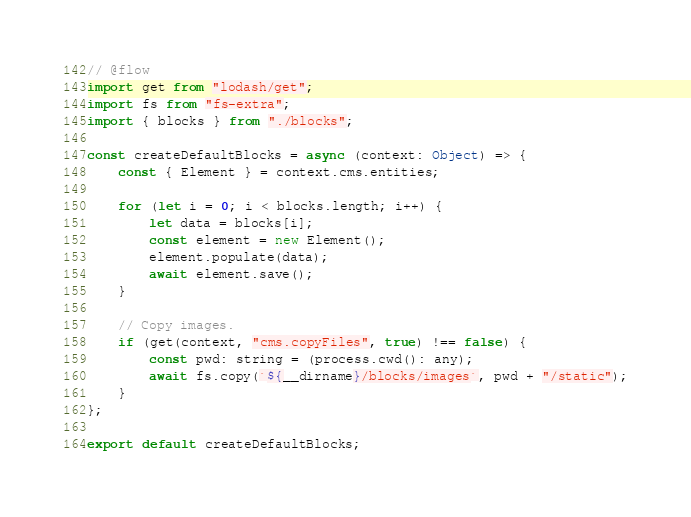Convert code to text. <code><loc_0><loc_0><loc_500><loc_500><_JavaScript_>// @flow
import get from "lodash/get";
import fs from "fs-extra";
import { blocks } from "./blocks";

const createDefaultBlocks = async (context: Object) => {
    const { Element } = context.cms.entities;

    for (let i = 0; i < blocks.length; i++) {
        let data = blocks[i];
        const element = new Element();
        element.populate(data);
        await element.save();
    }

    // Copy images.
    if (get(context, "cms.copyFiles", true) !== false) {
        const pwd: string = (process.cwd(): any);
        await fs.copy(`${__dirname}/blocks/images`, pwd + "/static");
    }
};

export default createDefaultBlocks;
</code> 